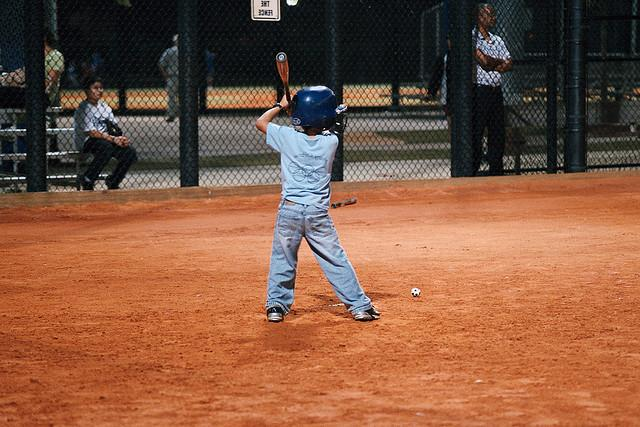What part of his uniform is he least likely to wear if he plays when he's older? Please explain your reasoning. jeans. These will become too small as he gets bigger 